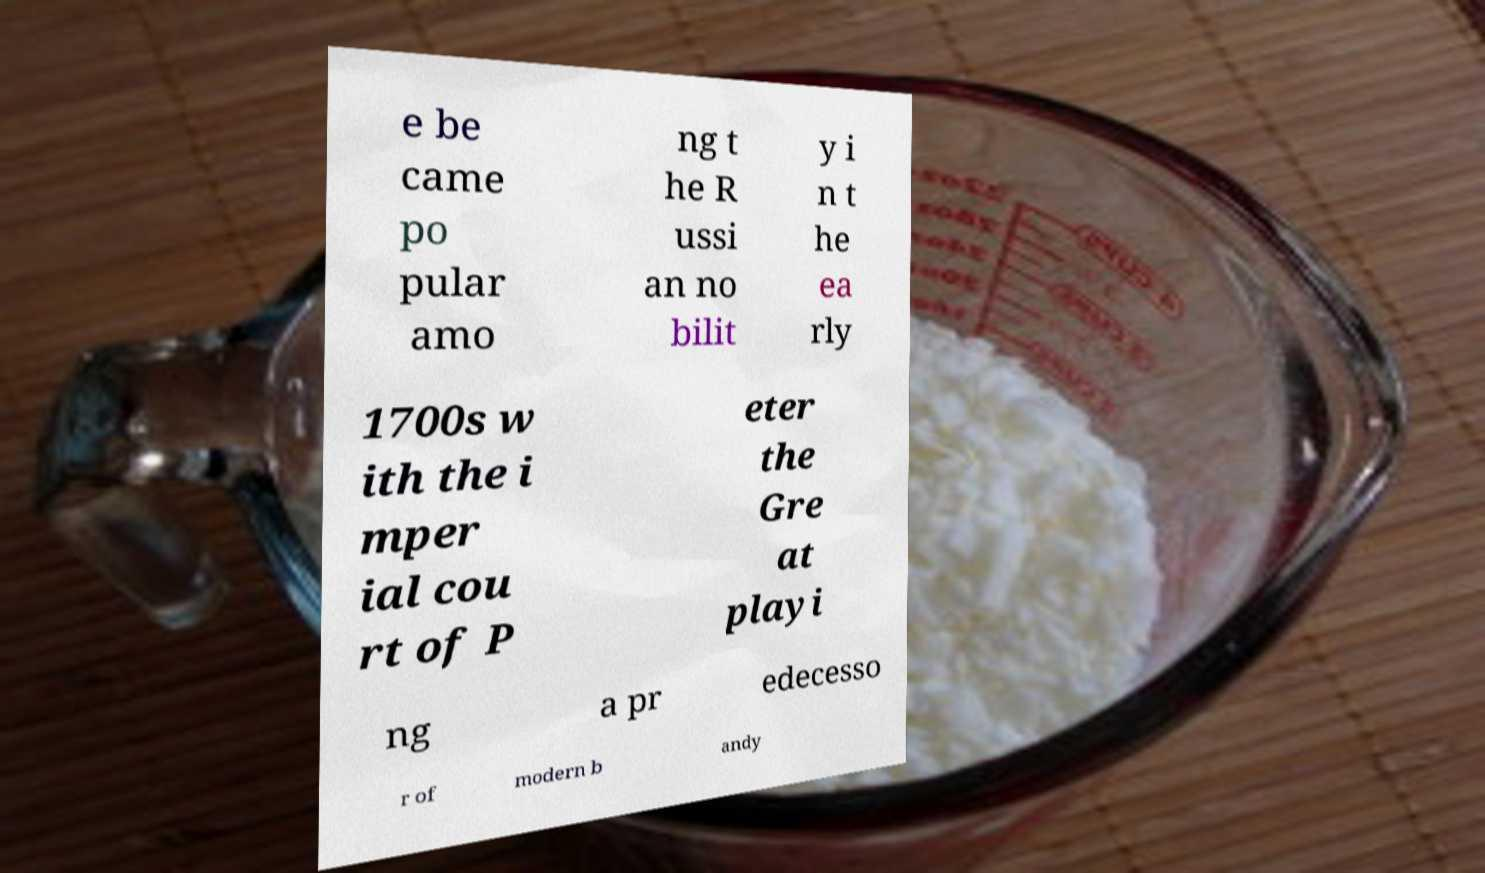Could you assist in decoding the text presented in this image and type it out clearly? e be came po pular amo ng t he R ussi an no bilit y i n t he ea rly 1700s w ith the i mper ial cou rt of P eter the Gre at playi ng a pr edecesso r of modern b andy 